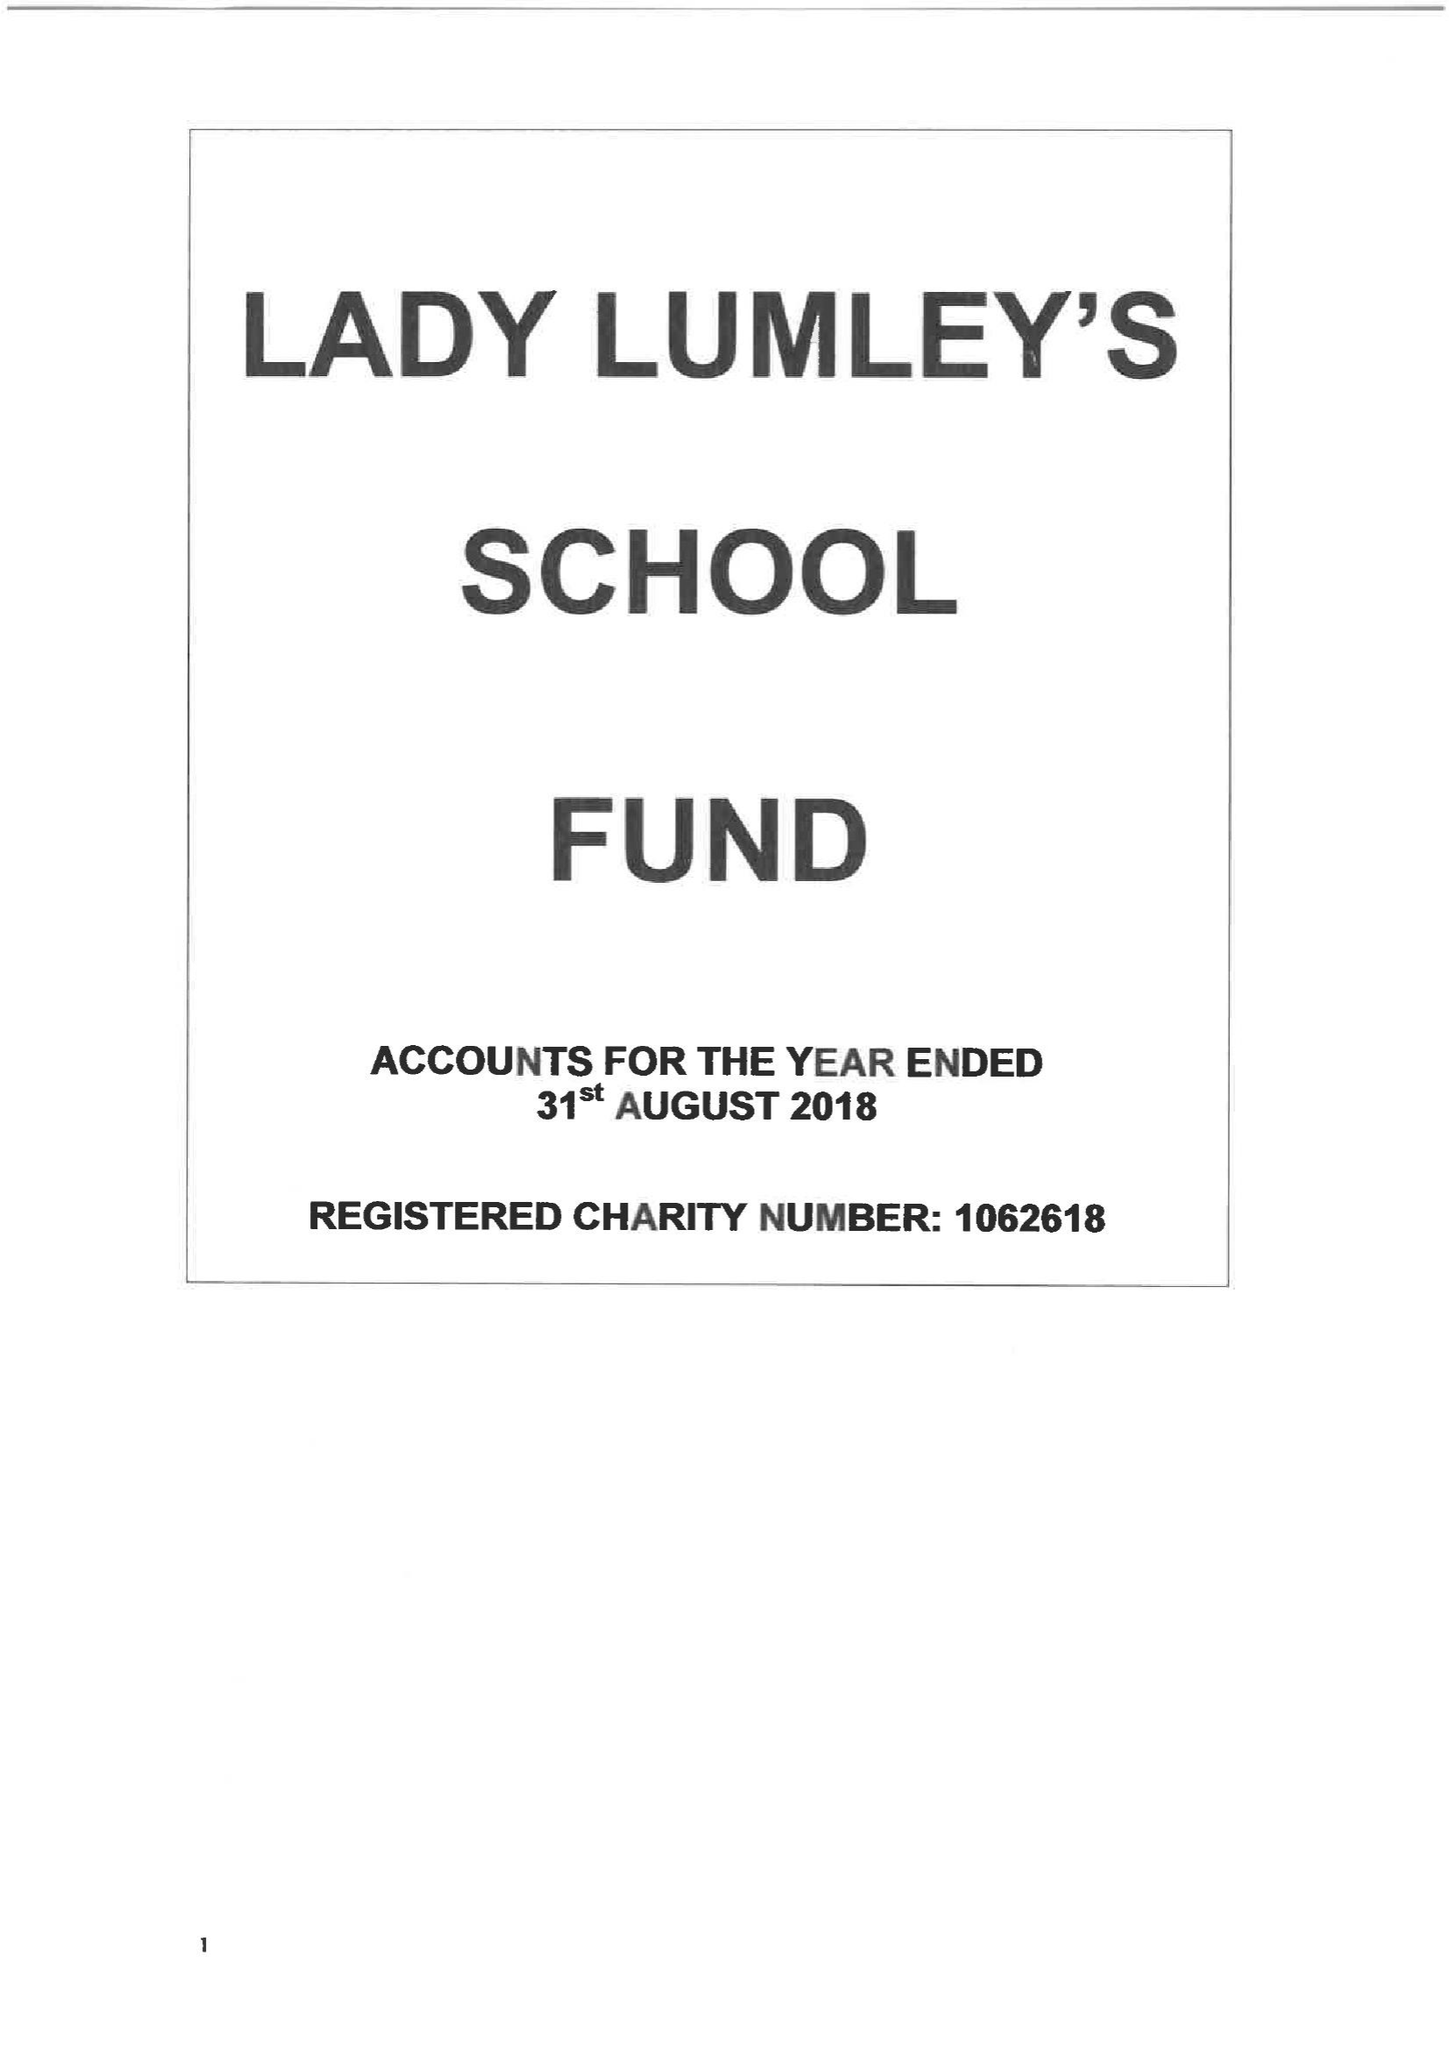What is the value for the charity_number?
Answer the question using a single word or phrase. 1062618 